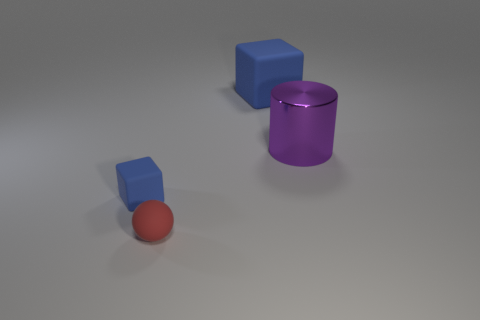What number of cubes have the same material as the small ball?
Your response must be concise. 2. What size is the other object that is the same shape as the large blue matte object?
Provide a succinct answer. Small. Is the purple cylinder the same size as the red object?
Make the answer very short. No. There is a thing that is on the left side of the tiny thing that is right of the block in front of the metal cylinder; what is its shape?
Your answer should be compact. Cube. What color is the small rubber object that is the same shape as the large blue thing?
Give a very brief answer. Blue. What size is the thing that is right of the tiny red rubber sphere and left of the cylinder?
Offer a terse response. Large. What number of objects are behind the thing in front of the blue rubber object left of the small red sphere?
Make the answer very short. 3. How many tiny things are metal cylinders or cyan matte cubes?
Keep it short and to the point. 0. Is the blue object left of the red thing made of the same material as the large blue block?
Your answer should be very brief. Yes. What is the block on the left side of the blue thing behind the blue rubber thing that is left of the big blue block made of?
Offer a terse response. Rubber. 